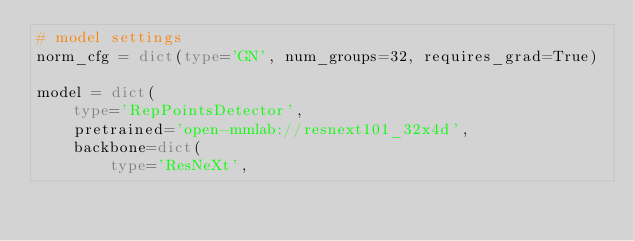<code> <loc_0><loc_0><loc_500><loc_500><_Python_># model settings
norm_cfg = dict(type='GN', num_groups=32, requires_grad=True)

model = dict(
    type='RepPointsDetector',
    pretrained='open-mmlab://resnext101_32x4d',
    backbone=dict(
        type='ResNeXt',</code> 